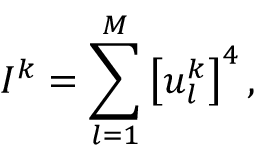Convert formula to latex. <formula><loc_0><loc_0><loc_500><loc_500>I ^ { k } = \sum _ { l = 1 } ^ { M } \left [ u _ { l } ^ { k } \right ] ^ { 4 } ,</formula> 